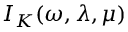Convert formula to latex. <formula><loc_0><loc_0><loc_500><loc_500>\mathcal { I } _ { K } ( \omega , \lambda , \mu )</formula> 